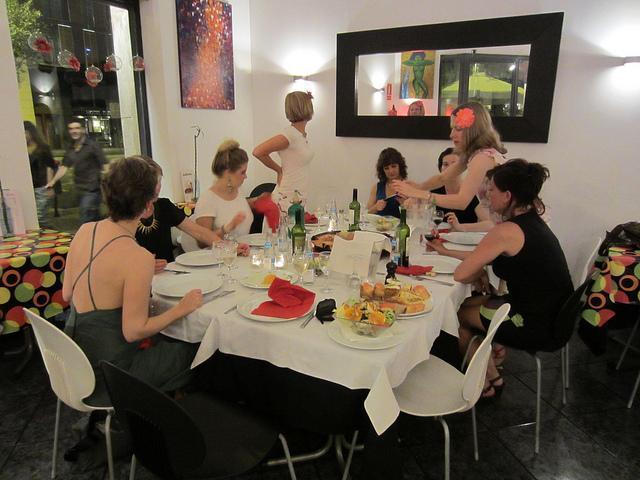How many women are wearing white dresses?
Give a very brief answer. 2. How many people are there?
Give a very brief answer. 8. How many hanging plants are there?
Give a very brief answer. 1. How many real people are in the picture?
Give a very brief answer. 8. How many people are sitting at the table?
Give a very brief answer. 8. How many people are in the photo?
Give a very brief answer. 7. How many chairs can be seen?
Give a very brief answer. 4. How many cats are on the car?
Give a very brief answer. 0. 